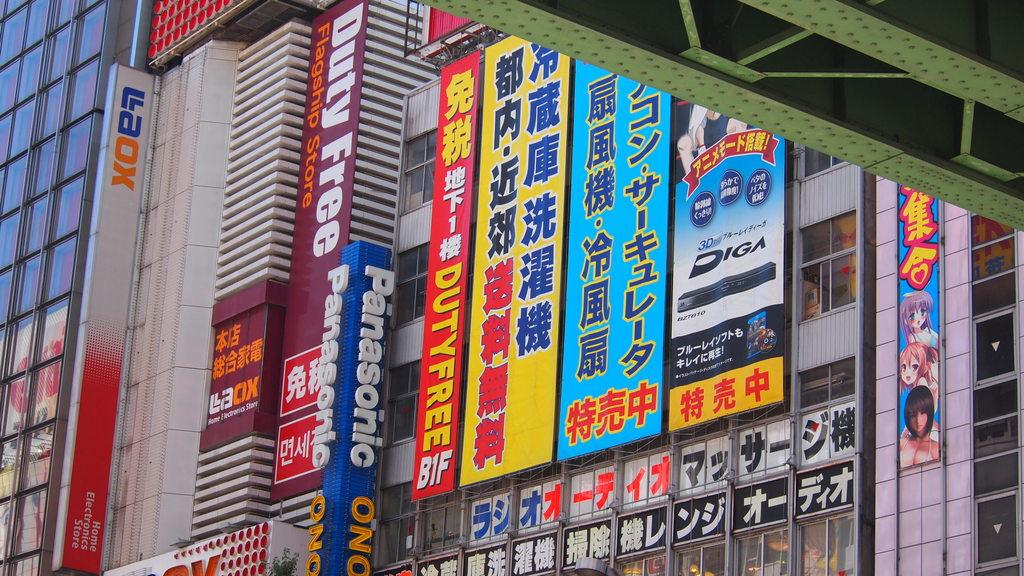What type of structures can be seen in the image? There are buildings in the image. What else is visible in the image besides the buildings? Boards are visible in the image. What type of muscle can be seen flexing in the image? There is no muscle visible in the image; it only features buildings and boards. 